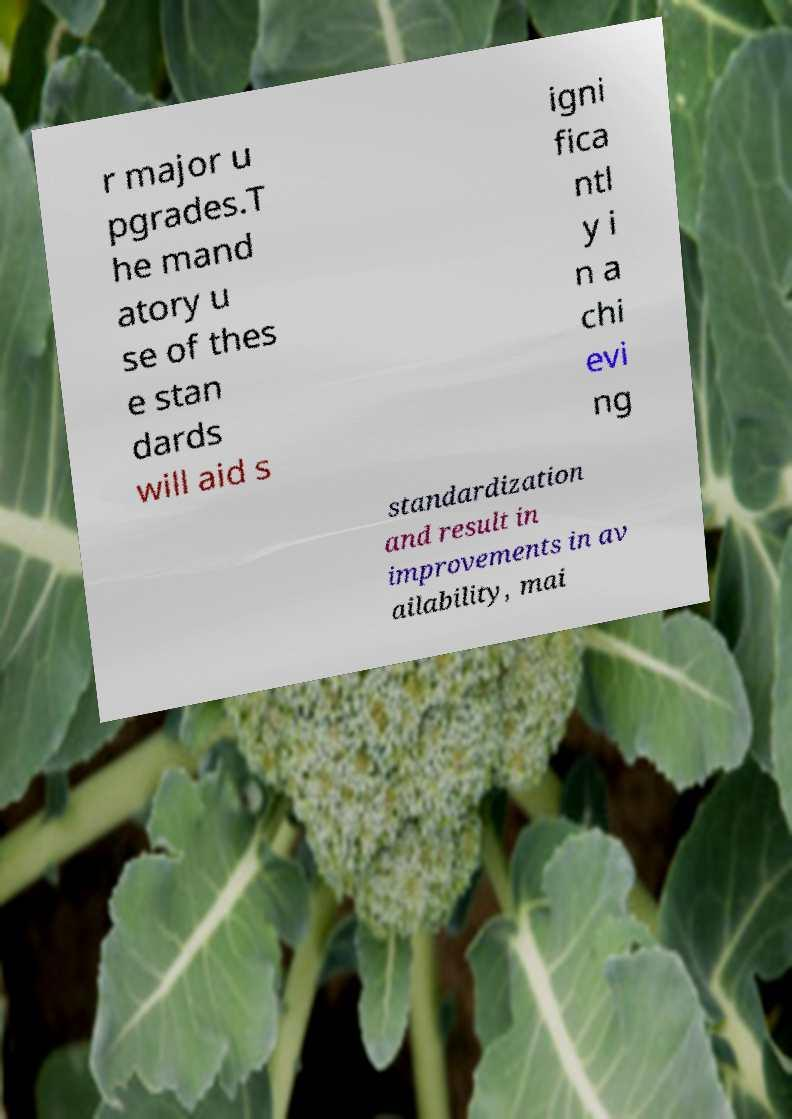Please identify and transcribe the text found in this image. r major u pgrades.T he mand atory u se of thes e stan dards will aid s igni fica ntl y i n a chi evi ng standardization and result in improvements in av ailability, mai 